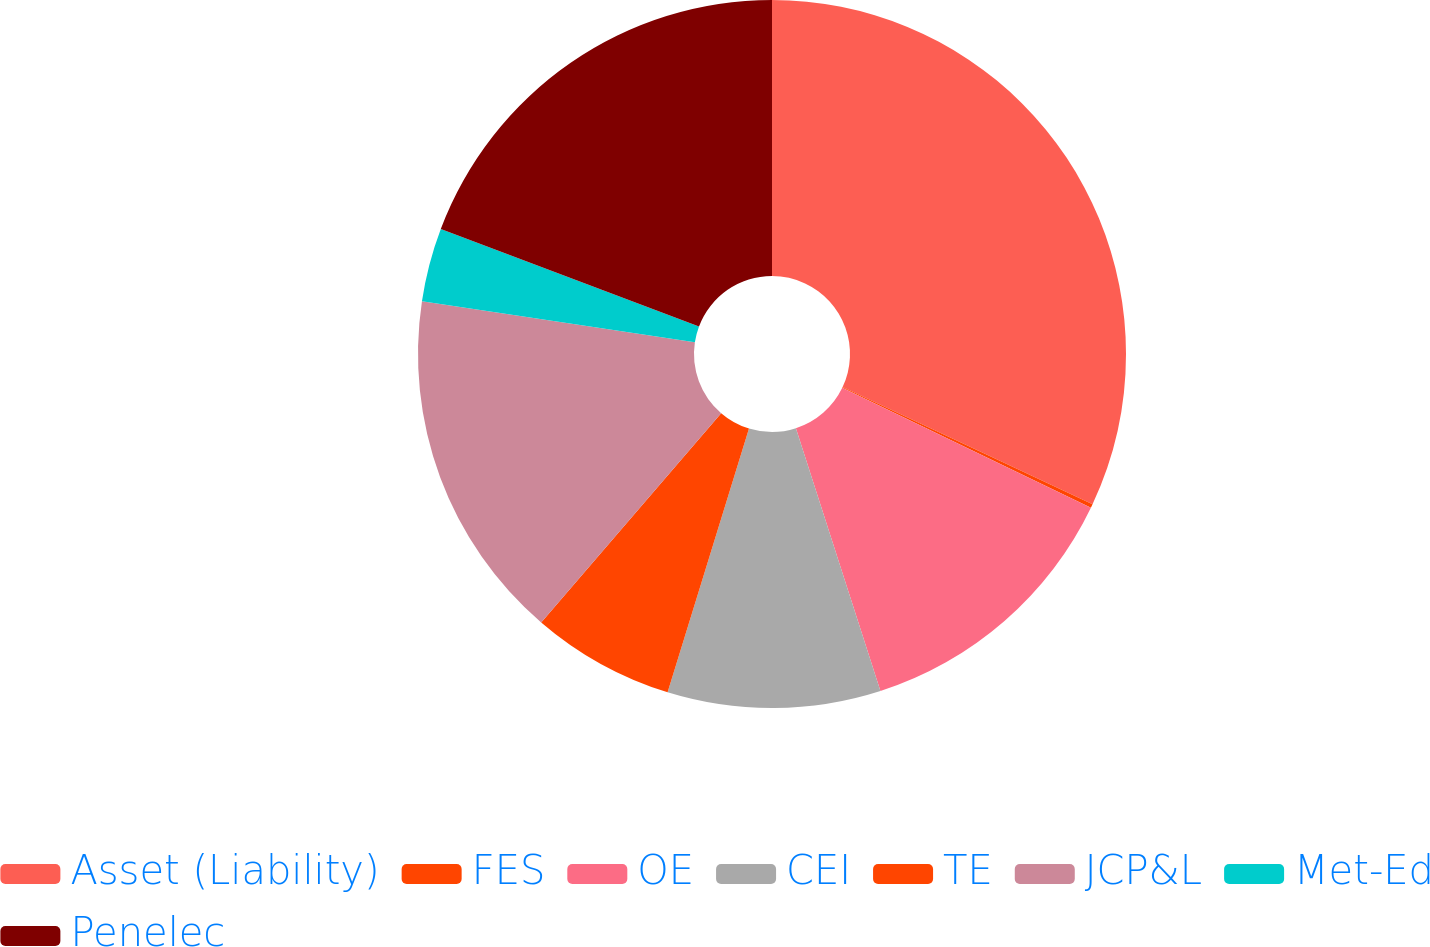Convert chart to OTSL. <chart><loc_0><loc_0><loc_500><loc_500><pie_chart><fcel>Asset (Liability)<fcel>FES<fcel>OE<fcel>CEI<fcel>TE<fcel>JCP&L<fcel>Met-Ed<fcel>Penelec<nl><fcel>31.98%<fcel>0.17%<fcel>12.9%<fcel>9.72%<fcel>6.54%<fcel>16.08%<fcel>3.36%<fcel>19.26%<nl></chart> 